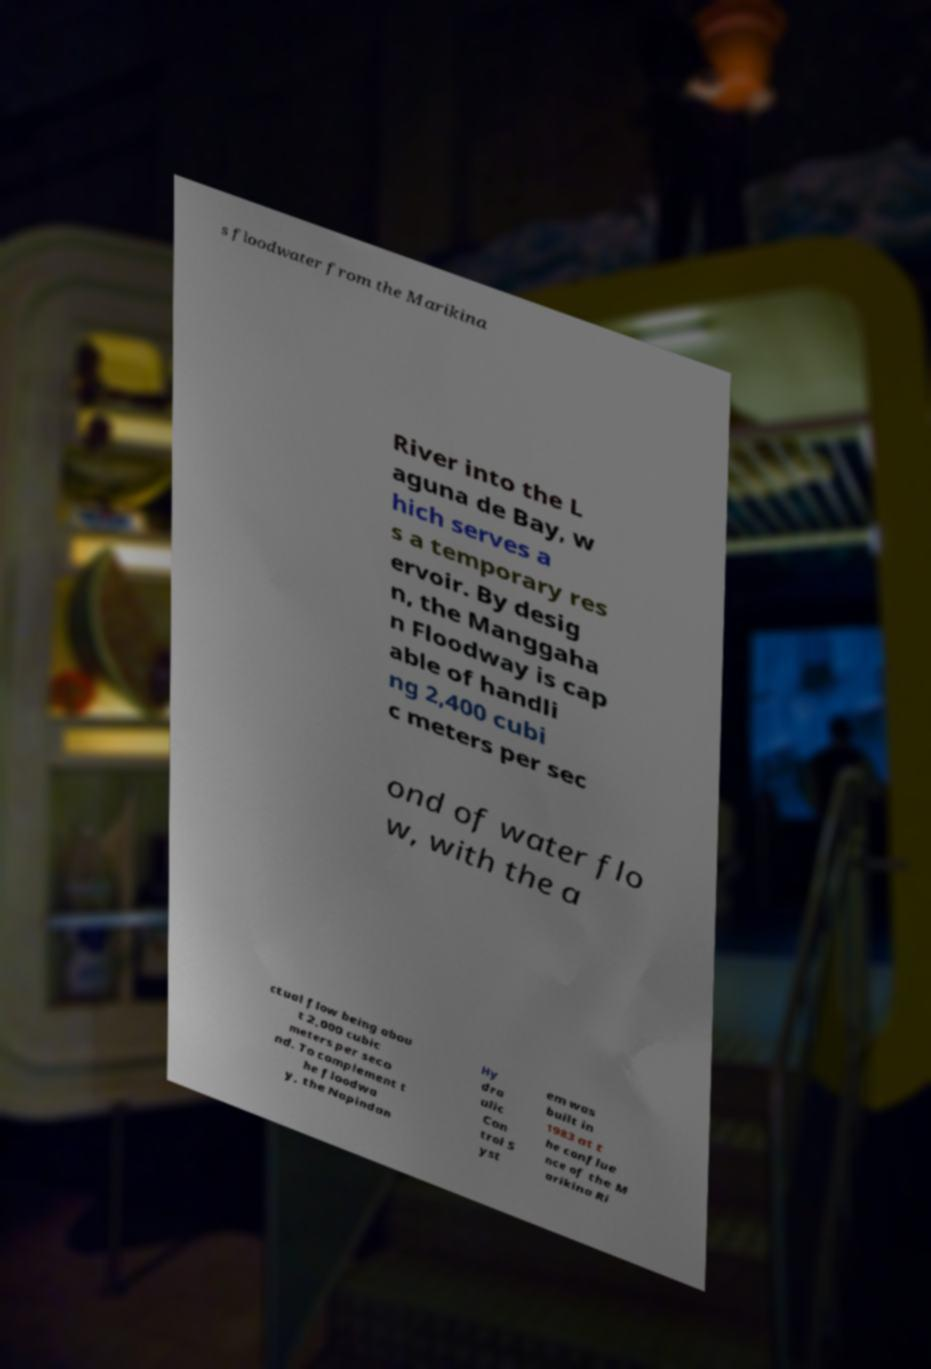For documentation purposes, I need the text within this image transcribed. Could you provide that? s floodwater from the Marikina River into the L aguna de Bay, w hich serves a s a temporary res ervoir. By desig n, the Manggaha n Floodway is cap able of handli ng 2,400 cubi c meters per sec ond of water flo w, with the a ctual flow being abou t 2,000 cubic meters per seco nd. To complement t he floodwa y, the Napindan Hy dra ulic Con trol S yst em was built in 1983 at t he conflue nce of the M arikina Ri 